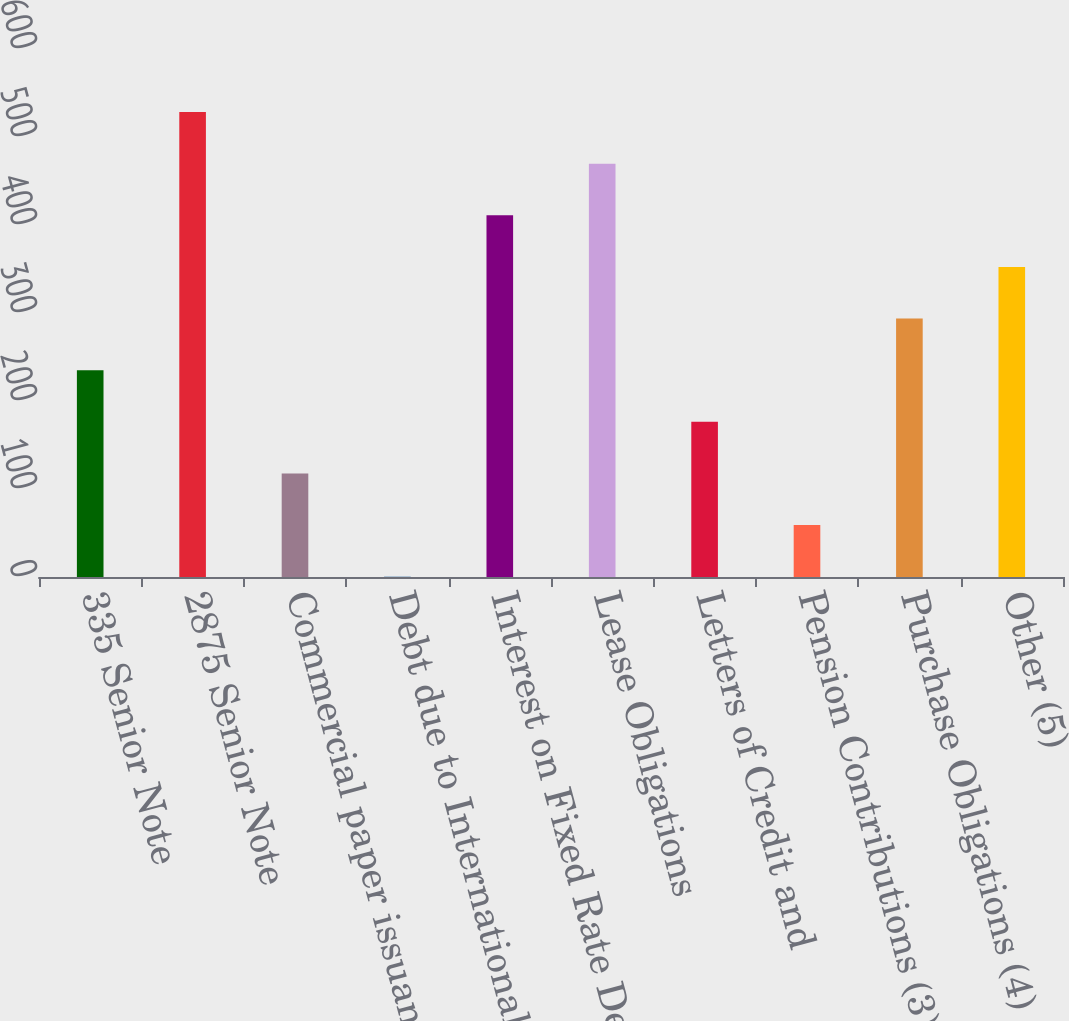Convert chart to OTSL. <chart><loc_0><loc_0><loc_500><loc_500><bar_chart><fcel>335 Senior Note<fcel>2875 Senior Note<fcel>Commercial paper issuances<fcel>Debt due to International<fcel>Interest on Fixed Rate Debt<fcel>Lease Obligations<fcel>Letters of Credit and<fcel>Pension Contributions (3)<fcel>Purchase Obligations (4)<fcel>Other (5)<nl><fcel>235.02<fcel>528.37<fcel>117.68<fcel>0.34<fcel>411.03<fcel>469.7<fcel>176.35<fcel>59.01<fcel>293.69<fcel>352.36<nl></chart> 